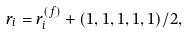Convert formula to latex. <formula><loc_0><loc_0><loc_500><loc_500>r _ { i } = r _ { i } ^ { ( f ) } + ( 1 , 1 , 1 , 1 , 1 ) / 2 ,</formula> 